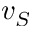Convert formula to latex. <formula><loc_0><loc_0><loc_500><loc_500>v _ { S }</formula> 